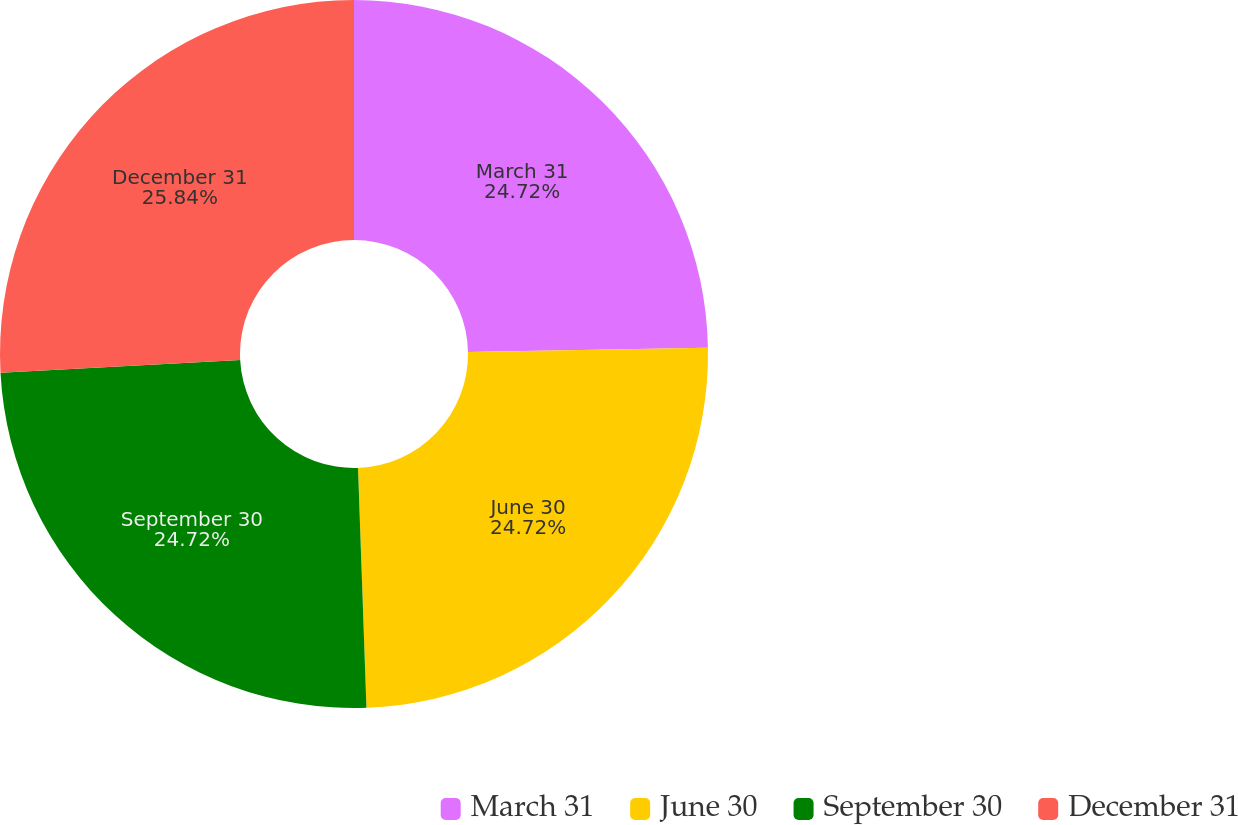Convert chart to OTSL. <chart><loc_0><loc_0><loc_500><loc_500><pie_chart><fcel>March 31<fcel>June 30<fcel>September 30<fcel>December 31<nl><fcel>24.72%<fcel>24.72%<fcel>24.72%<fcel>25.84%<nl></chart> 